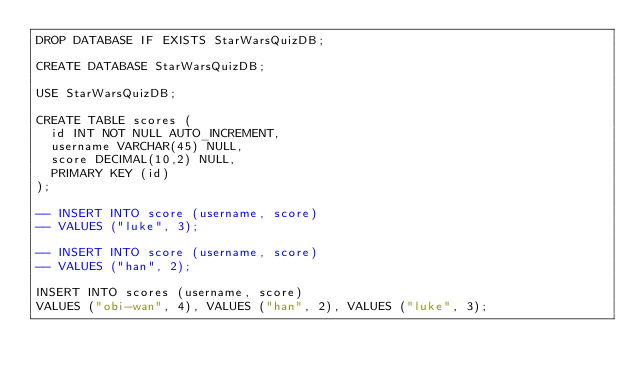Convert code to text. <code><loc_0><loc_0><loc_500><loc_500><_SQL_>DROP DATABASE IF EXISTS StarWarsQuizDB;

CREATE DATABASE StarWarsQuizDB;

USE StarWarsQuizDB;

CREATE TABLE scores (
  id INT NOT NULL AUTO_INCREMENT,
  username VARCHAR(45) NULL,
  score DECIMAL(10,2) NULL,
  PRIMARY KEY (id)
);

-- INSERT INTO score (username, score)
-- VALUES ("luke", 3);

-- INSERT INTO score (username, score)
-- VALUES ("han", 2);

INSERT INTO scores (username, score)
VALUES ("obi-wan", 4), VALUES ("han", 2), VALUES ("luke", 3);</code> 